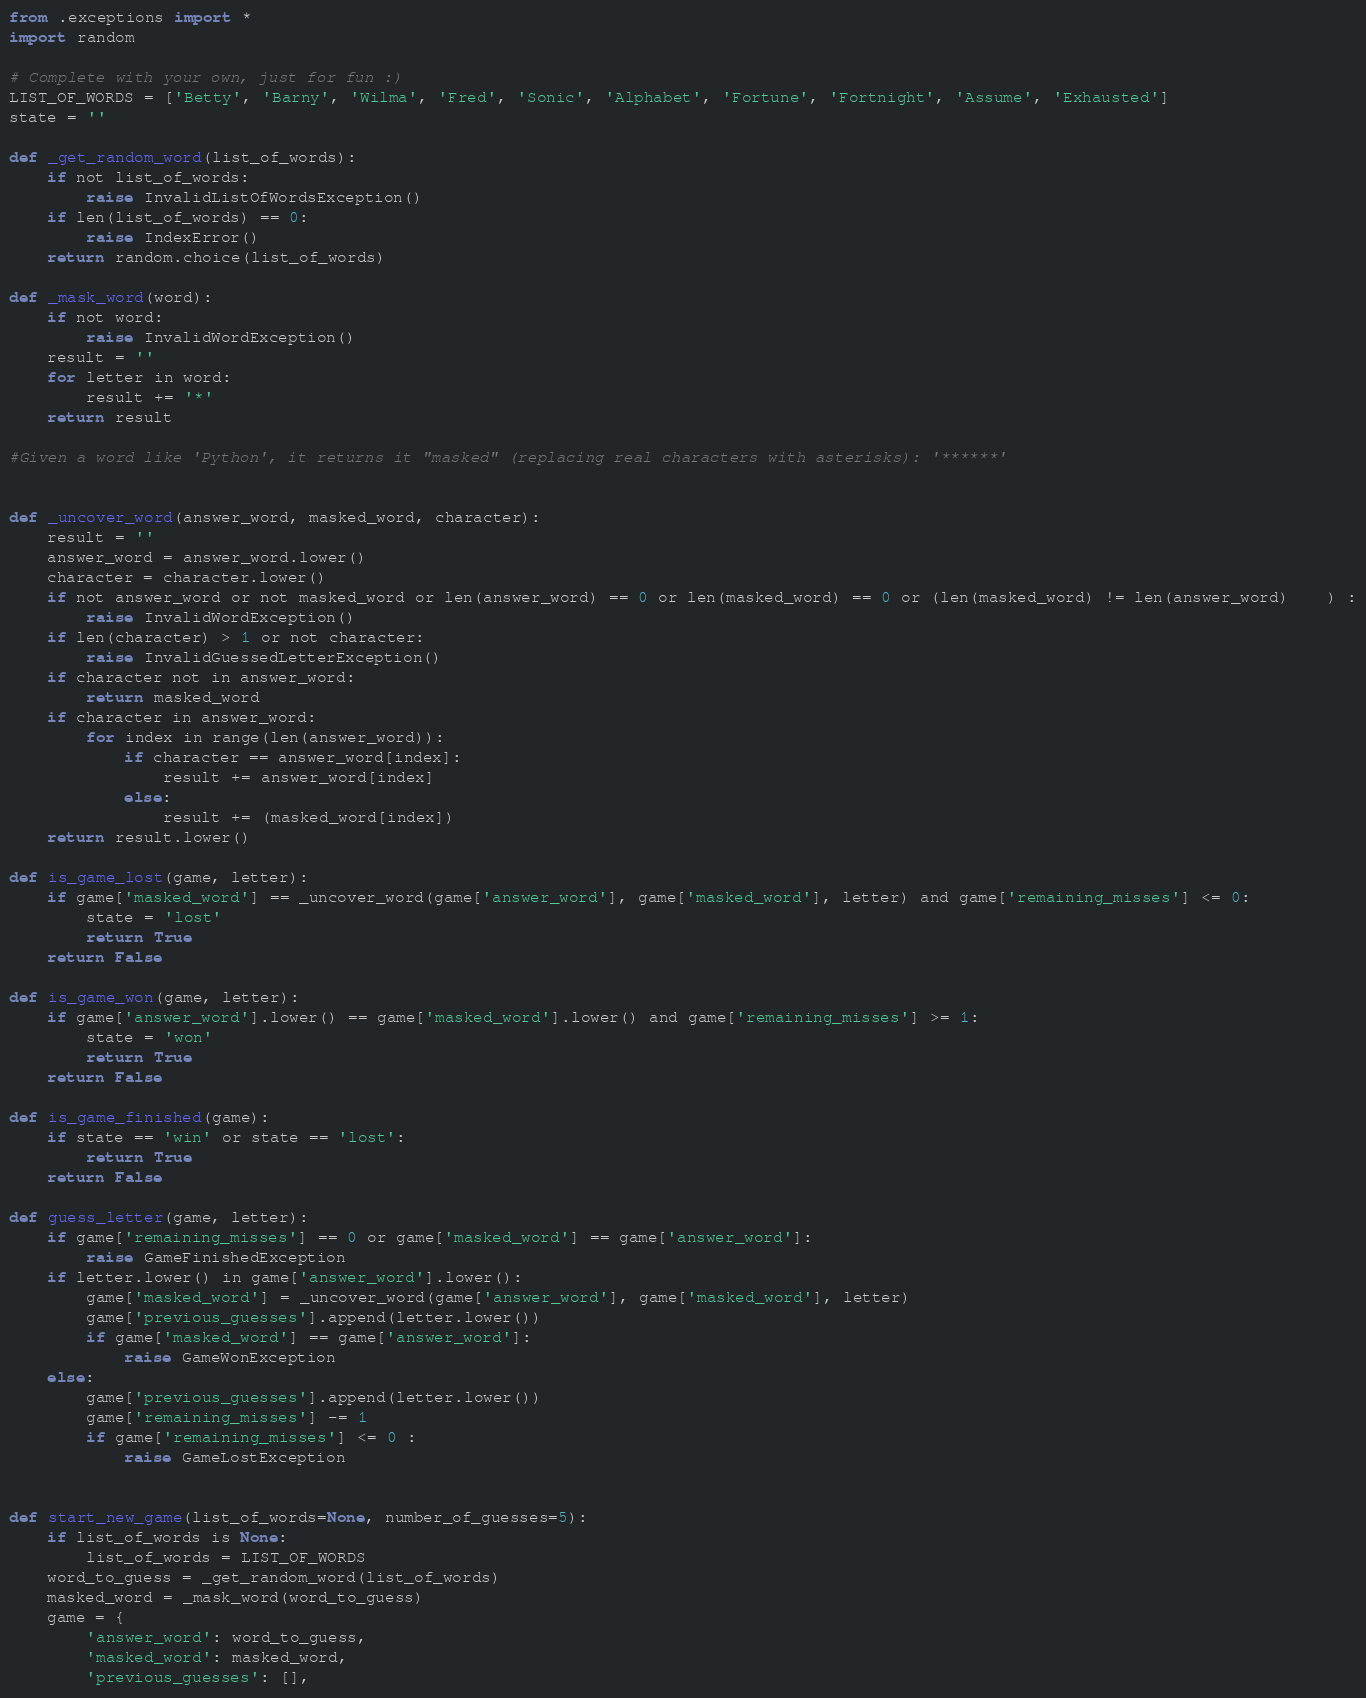<code> <loc_0><loc_0><loc_500><loc_500><_Python_>from .exceptions import *
import random

# Complete with your own, just for fun :)
LIST_OF_WORDS = ['Betty', 'Barny', 'Wilma', 'Fred', 'Sonic', 'Alphabet', 'Fortune', 'Fortnight', 'Assume', 'Exhausted']
state = ''

def _get_random_word(list_of_words):
    if not list_of_words:
        raise InvalidListOfWordsException()
    if len(list_of_words) == 0:
        raise IndexError()
    return random.choice(list_of_words)

def _mask_word(word):
    if not word:
        raise InvalidWordException()
    result = ''
    for letter in word:
        result += '*'
    return result

#Given a word like 'Python', it returns it "masked" (replacing real characters with asterisks): '******'


def _uncover_word(answer_word, masked_word, character):
    result = ''
    answer_word = answer_word.lower()
    character = character.lower()
    if not answer_word or not masked_word or len(answer_word) == 0 or len(masked_word) == 0 or (len(masked_word) != len(answer_word)    ) :
        raise InvalidWordException()
    if len(character) > 1 or not character:
        raise InvalidGuessedLetterException()
    if character not in answer_word:
        return masked_word
    if character in answer_word:
        for index in range(len(answer_word)):
            if character == answer_word[index]:
                result += answer_word[index]
            else:
                result += (masked_word[index])
    return result.lower()

def is_game_lost(game, letter):
    if game['masked_word'] == _uncover_word(game['answer_word'], game['masked_word'], letter) and game['remaining_misses'] <= 0:
        state = 'lost'
        return True
    return False
        
def is_game_won(game, letter):
    if game['answer_word'].lower() == game['masked_word'].lower() and game['remaining_misses'] >= 1:
        state = 'won'
        return True
    return False

def is_game_finished(game):
    if state == 'win' or state == 'lost':
        return True
    return False

def guess_letter(game, letter):
    if game['remaining_misses'] == 0 or game['masked_word'] == game['answer_word']:
        raise GameFinishedException
    if letter.lower() in game['answer_word'].lower():
        game['masked_word'] = _uncover_word(game['answer_word'], game['masked_word'], letter)
        game['previous_guesses'].append(letter.lower())
        if game['masked_word'] == game['answer_word']:
            raise GameWonException
    else:
        game['previous_guesses'].append(letter.lower())
        game['remaining_misses'] -= 1
        if game['remaining_misses'] <= 0 :
            raise GameLostException
        
        
def start_new_game(list_of_words=None, number_of_guesses=5):
    if list_of_words is None:
        list_of_words = LIST_OF_WORDS
    word_to_guess = _get_random_word(list_of_words)
    masked_word = _mask_word(word_to_guess)
    game = {
        'answer_word': word_to_guess,
        'masked_word': masked_word,
        'previous_guesses': [],</code> 